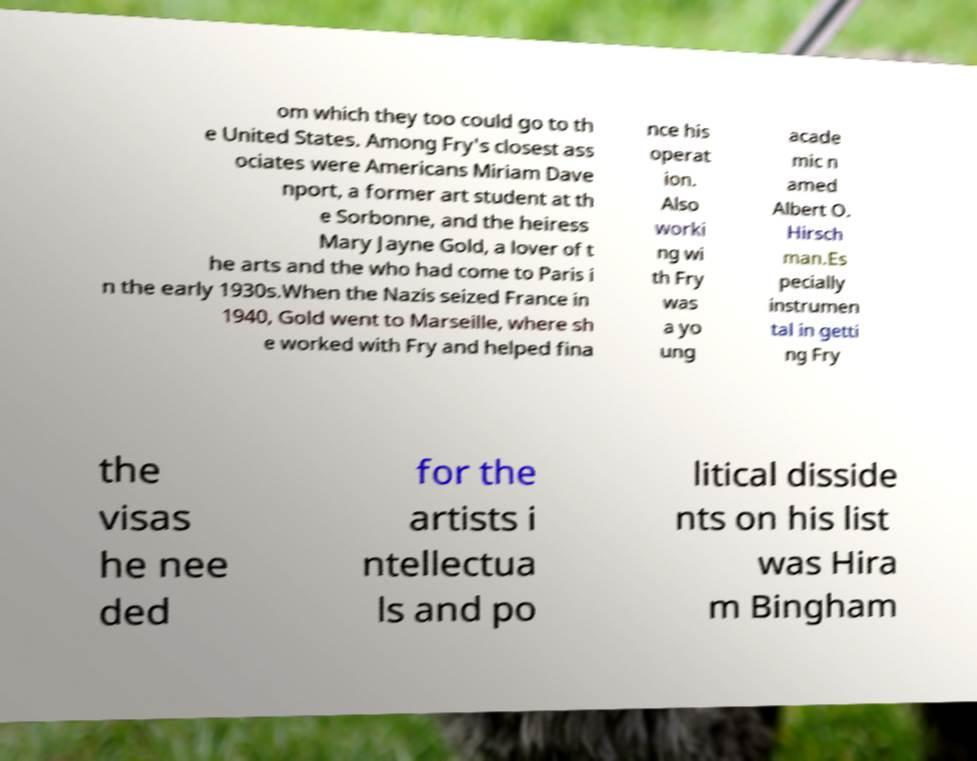What messages or text are displayed in this image? I need them in a readable, typed format. om which they too could go to th e United States. Among Fry's closest ass ociates were Americans Miriam Dave nport, a former art student at th e Sorbonne, and the heiress Mary Jayne Gold, a lover of t he arts and the who had come to Paris i n the early 1930s.When the Nazis seized France in 1940, Gold went to Marseille, where sh e worked with Fry and helped fina nce his operat ion. Also worki ng wi th Fry was a yo ung acade mic n amed Albert O. Hirsch man.Es pecially instrumen tal in getti ng Fry the visas he nee ded for the artists i ntellectua ls and po litical disside nts on his list was Hira m Bingham 